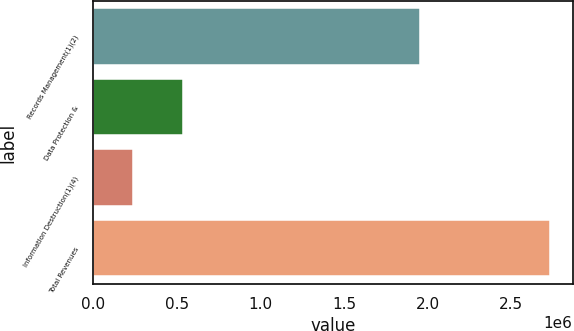Convert chart to OTSL. <chart><loc_0><loc_0><loc_500><loc_500><bar_chart><fcel>Records Management(1)(2)<fcel>Data Protection &<fcel>Information Destruction(1)(4)<fcel>Total Revenues<nl><fcel>1.95423e+06<fcel>536217<fcel>239585<fcel>2.73004e+06<nl></chart> 